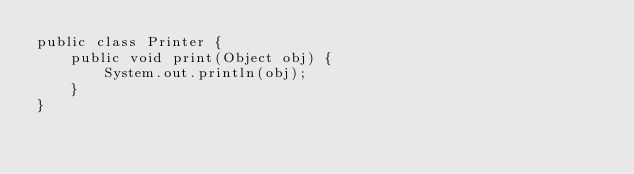Convert code to text. <code><loc_0><loc_0><loc_500><loc_500><_Java_>public class Printer {
    public void print(Object obj) {
        System.out.println(obj);
    }
}
</code> 